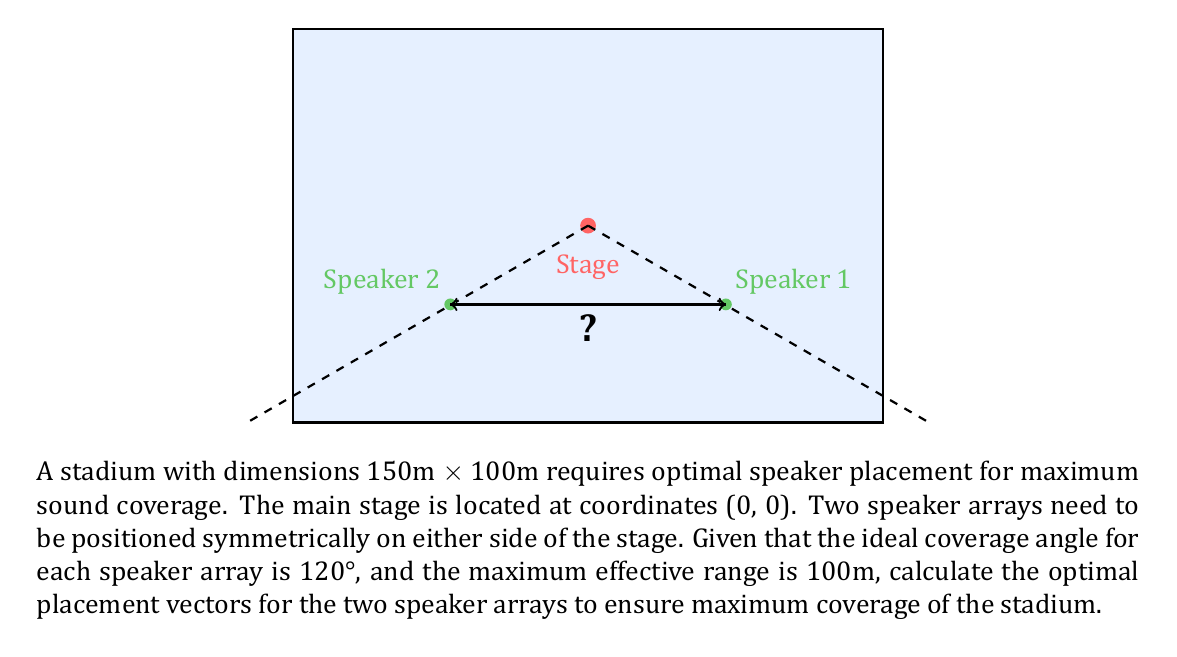Could you help me with this problem? To solve this problem, we'll follow these steps:

1) First, we need to determine the distance from the stage where the speakers should be placed. Given the 120° coverage angle, we can split this into two 60° angles on either side of the central axis.

2) The optimal placement will form an equilateral triangle with the stage and the far corner of the stadium. In an equilateral triangle, all sides are equal and all angles are 60°.

3) The distance from the stage to the far corner is:
   $$d = \sqrt{75^2 + 50^2} = \sqrt{5625 + 2500} = \sqrt{8125} \approx 90.14\text{m}$$

4) This distance is within the maximum effective range of 100m, so we can use it for our calculations.

5) Now, we can calculate the x and y components of the speaker placement vector:
   x-component: $90.14 \cdot \cos(60°) = 90.14 \cdot 0.5 = 45.07\text{m}$
   y-component: $90.14 \cdot \sin(60°) = 90.14 \cdot \frac{\sqrt{3}}{2} = 78.07\text{m}$

6) Therefore, the placement vectors for the two speaker arrays are:
   Speaker 1: $\vec{v_1} = (45.07, -20)$
   Speaker 2: $\vec{v_2} = (-45.07, -20)$

   Note: We use -20 for the y-component to place the speakers slightly in front of the stage for better coverage.

7) The distance between the two speaker arrays is:
   $$2 \cdot 45.07 = 90.14\text{m}$$

This placement ensures maximum coverage of the stadium while maintaining symmetry and optimal sound distribution.
Answer: Speaker 1: $\vec{v_1} = (45.07, -20)$, Speaker 2: $\vec{v_2} = (-45.07, -20)$ 